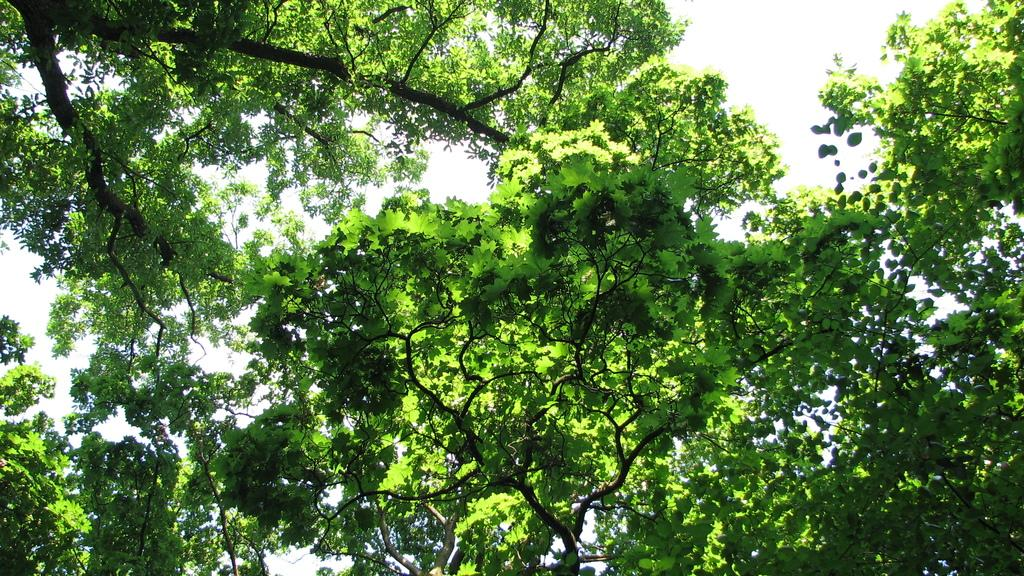What type of vegetation can be seen in the image? There are trees in the image. What is visible in the background of the image? The sky is visible in the background of the image. What type of drink is being held by the trees in the image? There are no drinks or people present in the image; it only features trees and the sky. 